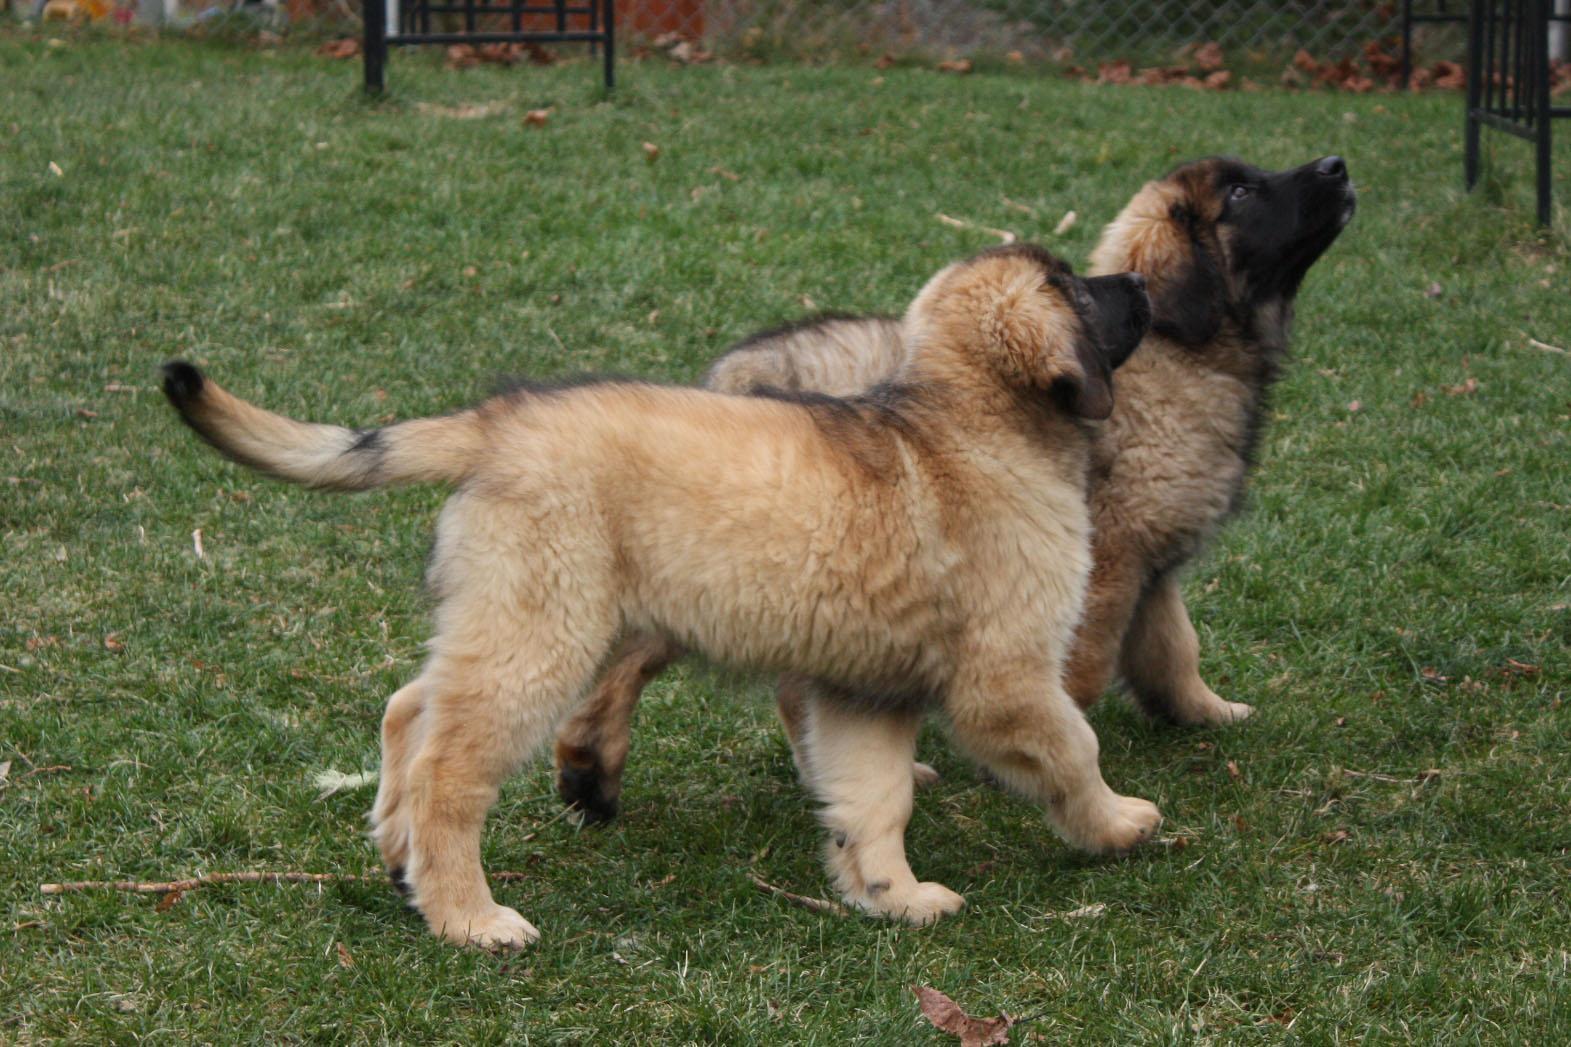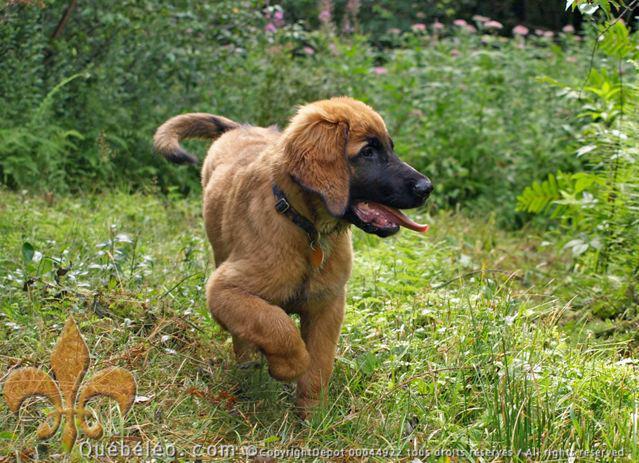The first image is the image on the left, the second image is the image on the right. Examine the images to the left and right. Is the description "There are two dogs outside in the grass in one of the images." accurate? Answer yes or no. Yes. The first image is the image on the left, the second image is the image on the right. Analyze the images presented: Is the assertion "In one image, three dogs are shown together on a ground containing water in one of its states of matter." valid? Answer yes or no. No. 